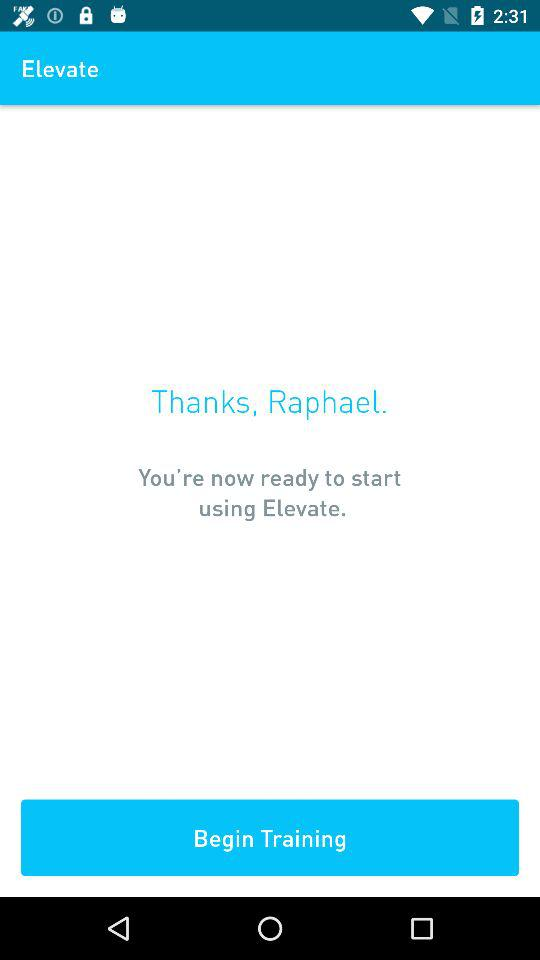What's the user name? The user name is Raphael. 